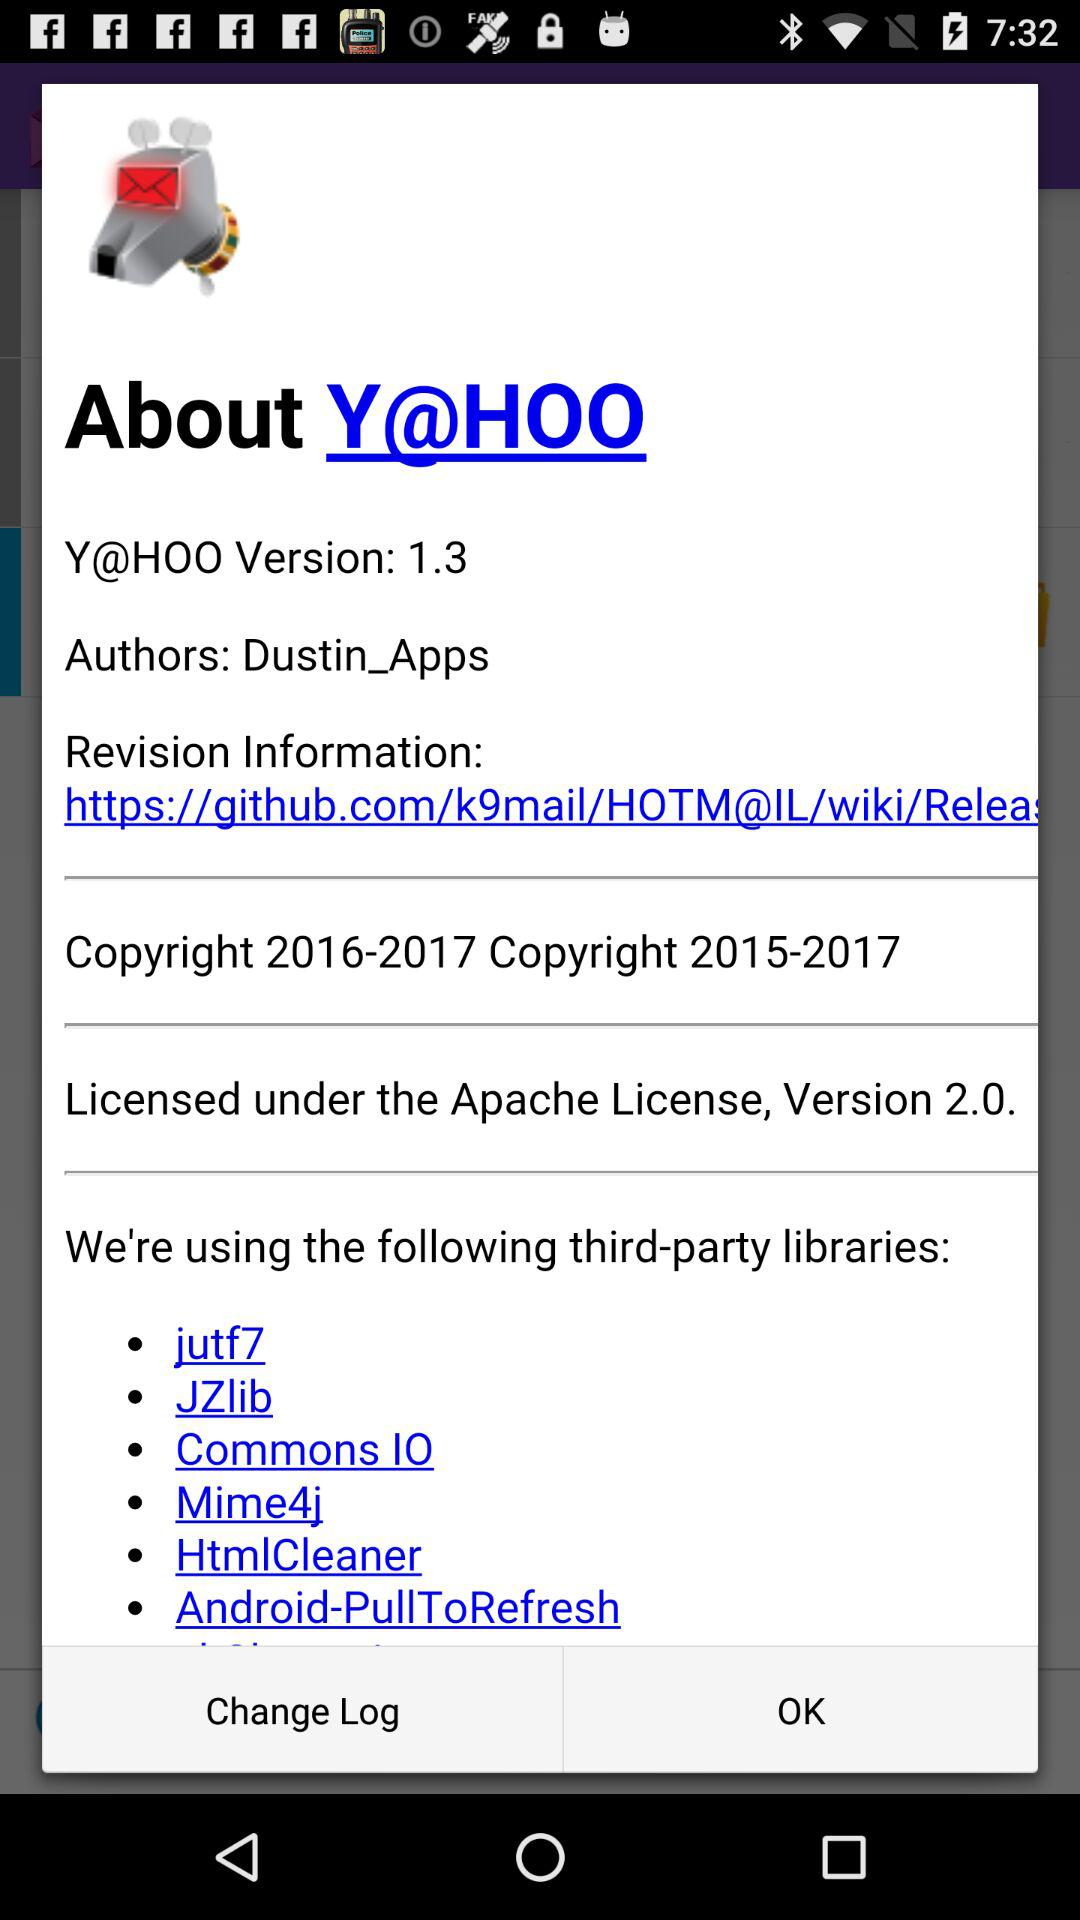How many third-party libraries are used?
Answer the question using a single word or phrase. 6 